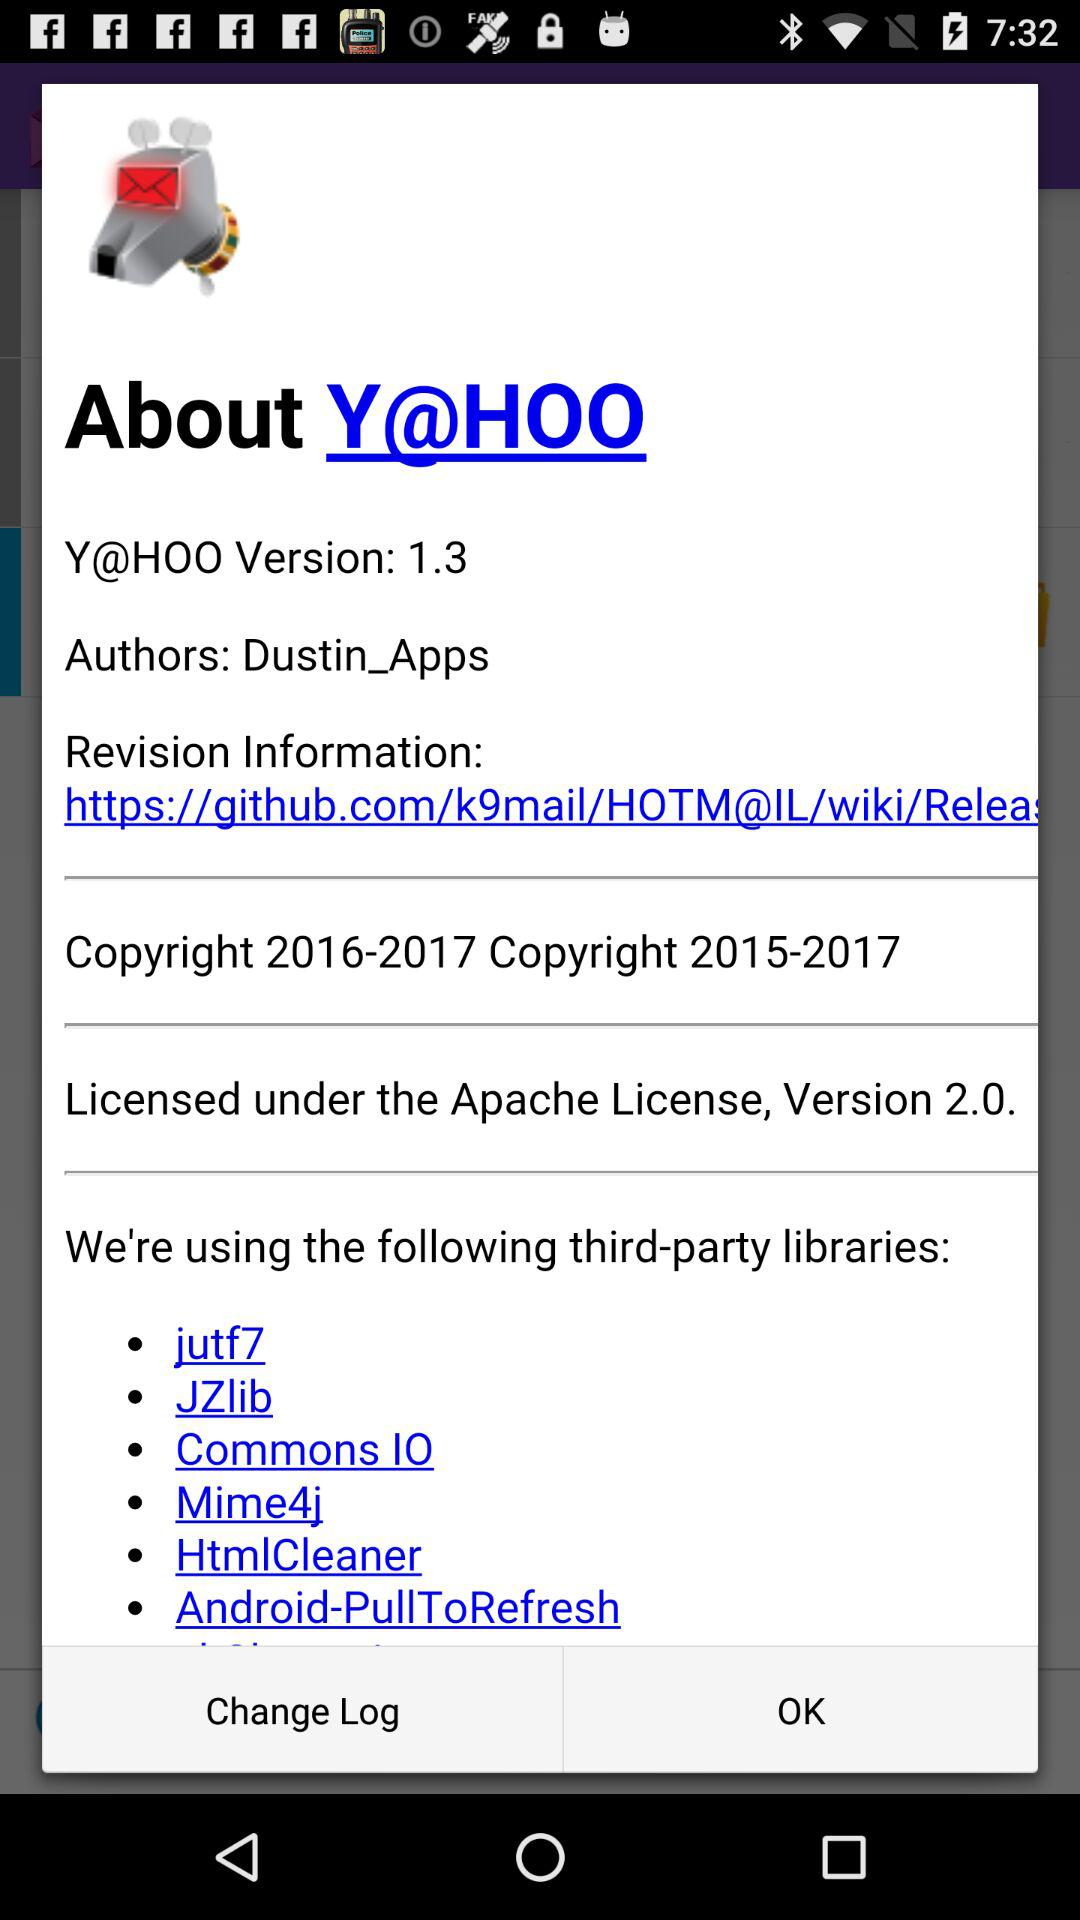How many third-party libraries are used?
Answer the question using a single word or phrase. 6 